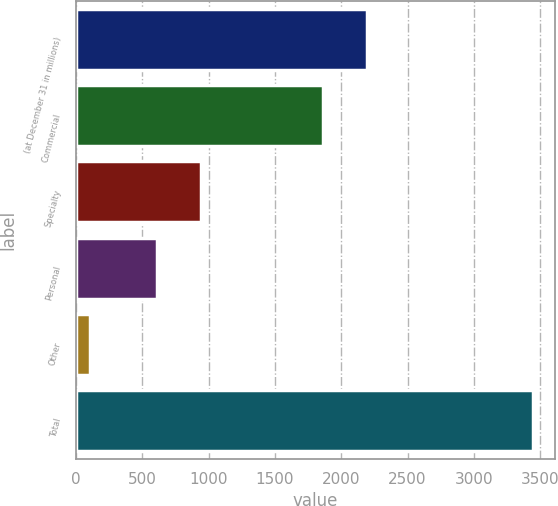<chart> <loc_0><loc_0><loc_500><loc_500><bar_chart><fcel>(at December 31 in millions)<fcel>Commercial<fcel>Specialty<fcel>Personal<fcel>Other<fcel>Total<nl><fcel>2195.5<fcel>1862<fcel>946.5<fcel>613<fcel>107<fcel>3442<nl></chart> 